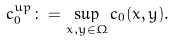Convert formula to latex. <formula><loc_0><loc_0><loc_500><loc_500>c ^ { u p } _ { 0 } \colon = \sup _ { x , y \in \Omega } c _ { 0 } ( x , y ) .</formula> 